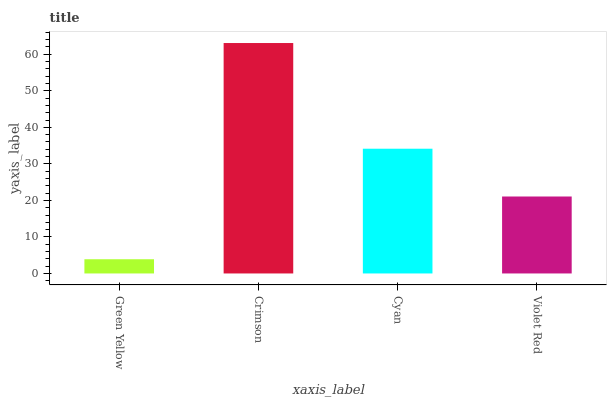Is Green Yellow the minimum?
Answer yes or no. Yes. Is Crimson the maximum?
Answer yes or no. Yes. Is Cyan the minimum?
Answer yes or no. No. Is Cyan the maximum?
Answer yes or no. No. Is Crimson greater than Cyan?
Answer yes or no. Yes. Is Cyan less than Crimson?
Answer yes or no. Yes. Is Cyan greater than Crimson?
Answer yes or no. No. Is Crimson less than Cyan?
Answer yes or no. No. Is Cyan the high median?
Answer yes or no. Yes. Is Violet Red the low median?
Answer yes or no. Yes. Is Violet Red the high median?
Answer yes or no. No. Is Green Yellow the low median?
Answer yes or no. No. 